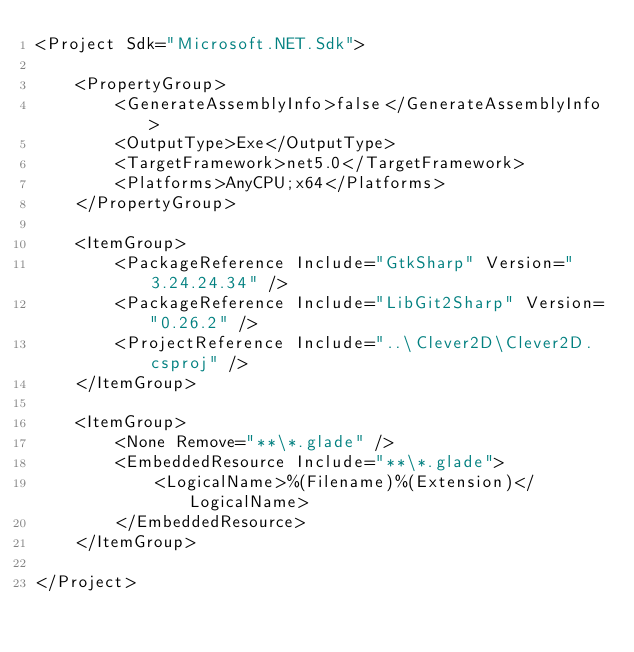Convert code to text. <code><loc_0><loc_0><loc_500><loc_500><_XML_><Project Sdk="Microsoft.NET.Sdk">

    <PropertyGroup>
        <GenerateAssemblyInfo>false</GenerateAssemblyInfo>
        <OutputType>Exe</OutputType>
        <TargetFramework>net5.0</TargetFramework>
        <Platforms>AnyCPU;x64</Platforms>
    </PropertyGroup>

    <ItemGroup>
        <PackageReference Include="GtkSharp" Version="3.24.24.34" />
        <PackageReference Include="LibGit2Sharp" Version="0.26.2" />
        <ProjectReference Include="..\Clever2D\Clever2D.csproj" />
    </ItemGroup>

    <ItemGroup>
        <None Remove="**\*.glade" />
        <EmbeddedResource Include="**\*.glade">
            <LogicalName>%(Filename)%(Extension)</LogicalName>
        </EmbeddedResource>
    </ItemGroup>

</Project>
</code> 